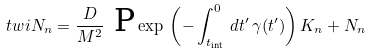Convert formula to latex. <formula><loc_0><loc_0><loc_500><loc_500>\ t w i N _ { n } = \frac { D } { M ^ { 2 } } \ \text {P} \exp \, \left ( - \int _ { t _ { \text {int} } } ^ { 0 } \, d t ^ { \prime } \, \gamma ( t ^ { \prime } ) \right ) K _ { n } + N _ { n }</formula> 